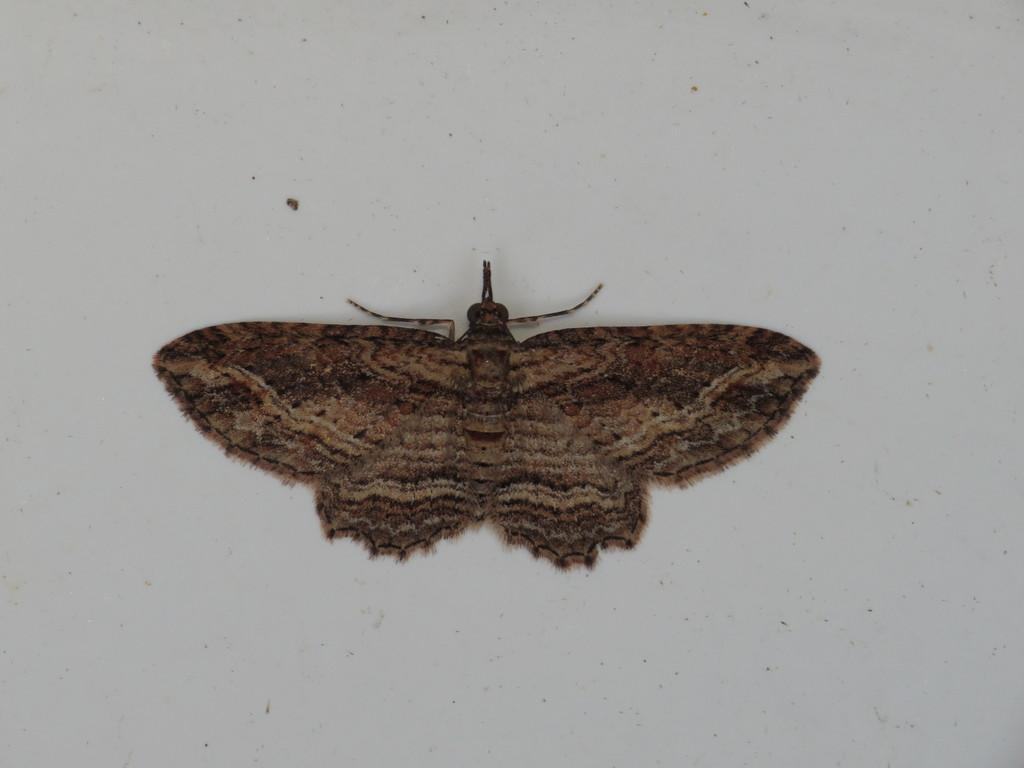What is the main subject of the image? There is an insect in the image. Where is the insect located in the image? The insect is in the middle of the image. What can be seen in the background of the image? The background of the image is plain. What is the opinion of the squirrel in the image? There is no squirrel present in the image, so it is not possible to determine its opinion. 